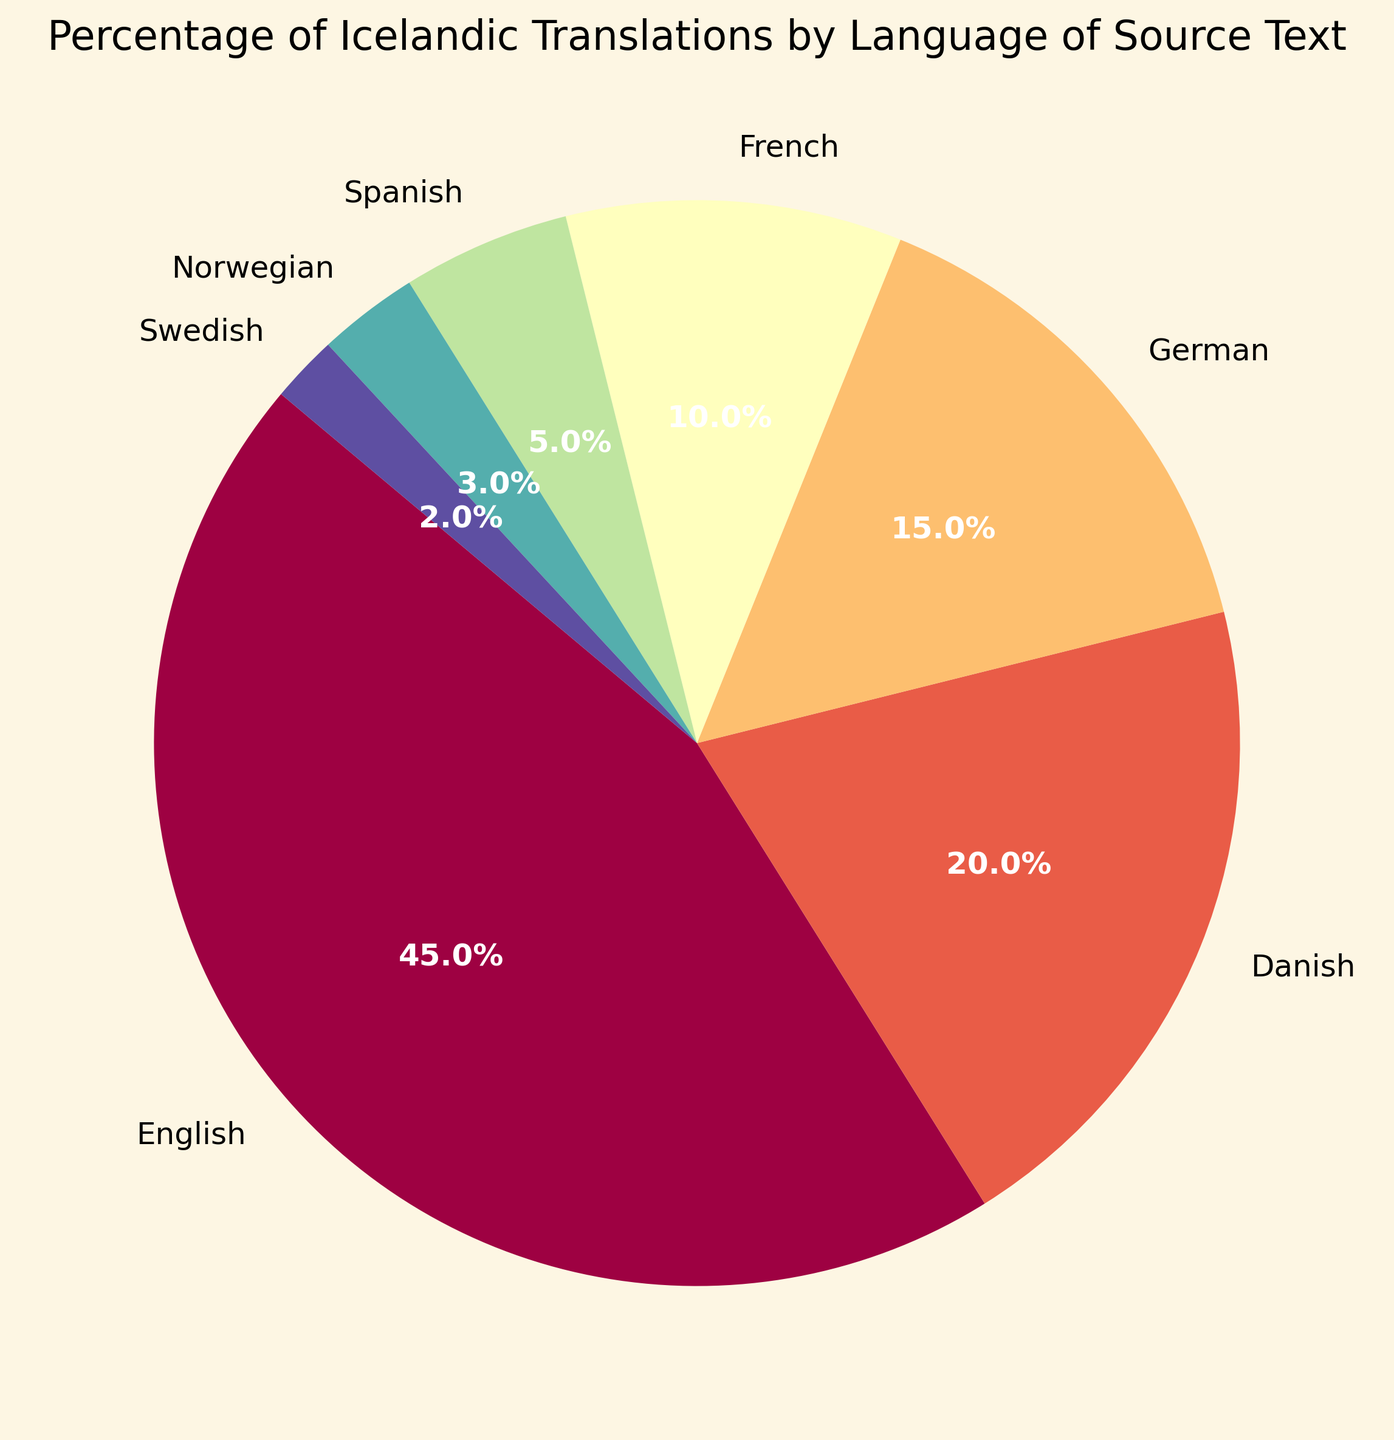What percentage of Icelandic translations come from English texts? The pie chart shows the percentage value for each language. According to the chart, English texts account for 45% of Icelandic translations.
Answer: 45% How many languages are shown in the pie chart? By counting the segments in the pie chart, you can see there are seven different languages represented.
Answer: 7 Which language has the smallest percentage of Icelandic translations? The pie chart indicates that Swedish has the smallest segment, representing just 2% of the translations.
Answer: Swedish Is the percentage of Icelandic translations from Danish texts greater than from German texts? By comparing the percentage values for Danish (20%) and German (15%), it is evident that Danish texts contribute a higher percentage than German texts.
Answer: Yes What is the combined percentage of Icelandic translations from Spanish and Norwegian texts? According to the chart, Spanish accounts for 5% and Norwegian accounts for 3%. Sum these values: 5% + 3% = 8%.
Answer: 8% Which language contributes more to Icelandic translations: French or Spanish? Comparing the segments for French and Spanish, French accounts for 10% while Spanish accounts for 5%, indicating French has a higher percentage.
Answer: French How does the percentage of translations from English texts compare to the percentages of Danish and German texts combined? The percentage for English texts is 45%. The combined percentage of Danish (20%) and German (15%) texts is 20% + 15% = 35%. Therefore, English contributes a higher percentage than Danish and German combined.
Answer: English is higher Which three languages have the highest percentages of translations, and what are their percentages? From the chart, the largest three segments are English (45%), Danish (20%), and German (15%).
Answer: English (45%), Danish (20%), German (15%) What is the difference in percentage between Icelandic translations from German texts and from French texts? The chart shows that German texts account for 15% and French texts for 10%. The difference between them is 15% - 10% = 5%.
Answer: 5% If you combine the percentages of translations for Norwegian, Swedish, and Spanish texts, is the total greater than the percentage for French texts? Norwegian is 3%, Swedish is 2%, and Spanish is 5%. Combined, they are 3% + 2% + 5% = 10%, which is equal to the percentage for French texts.
Answer: No 